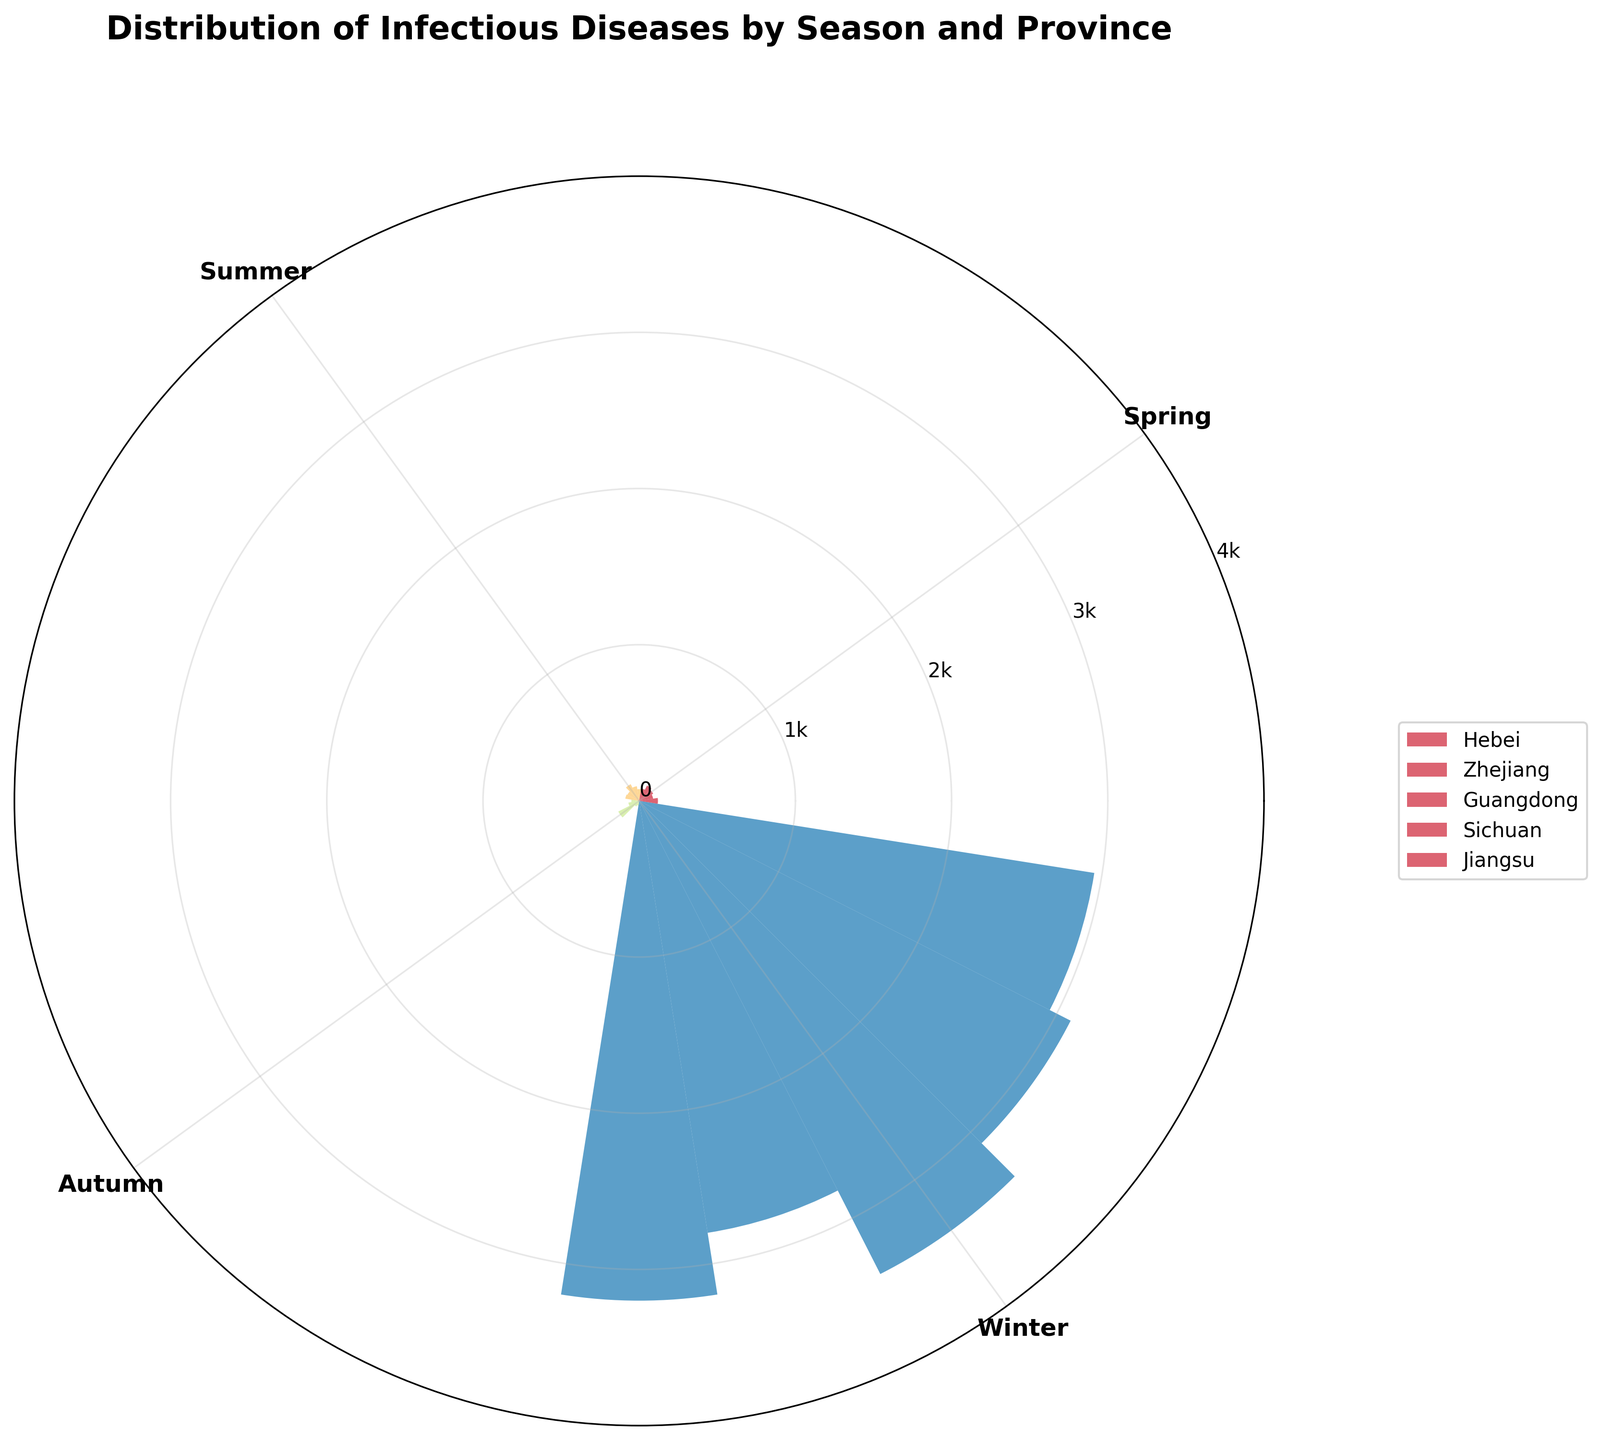How many provinces are included in the data? The legend in the plot lists the provinces included in the data. Each bar represents one province, and there is an entry for each in the legend. The provinces included are Hebei, Zhejiang, Guangdong, Sichuan, and Jiangsu.
Answer: 5 Which season has the highest case count of infectious diseases in Guangdong? The radial bars representing Guangdong show different lengths for each season. The bar corresponding to "Winter" is the longest, indicating the highest case count.
Answer: Winter What is the total case count for Dengue in all provinces during Autumn? Identify the heights of the bars for Dengue in Autumn for each province and sum them up (Hebei: 50, Zhejiang: 70, Guangdong: 150, Sichuan: 40, Jiangsu: 30). The sum is \(50 + 70 + 150 + 40 + 30 = 340\).
Answer: 340 Which province has the lowest case count of Cholera during Summer? Looking at the length of the Cholera bars in Summer for each province, Sichuan has the shortest bar.
Answer: Sichuan Comparing Hebei and Zhejiang, which province has more cases of Measles during Spring? Compare the lengths of the bars for Measles in Spring for both provinces. Hebei has a longer bar than Zhejiang.
Answer: Hebei On average, how many cases of Influenza are there across the provinces during Winter? Find the Influenza case counts for all provinces during Winter (Hebei: 3200, Zhejiang: 2800, Guangdong: 3400, Sichuan: 3100, Jiangsu: 2950), sum them and divide by the number of provinces (5). The sum is \(3200 + 2800 + 3400 + 3100 + 2950 = 15450\), and the average is \(15450 / 5 = 3090\).
Answer: 3090 In which season is the total case count for infectious diseases the highest across all provinces? Sum the radii for each season across all provinces. 
- Spring: Measles (120 + 90 + 100 + 110 + 80 = 500)
- Summer: Cholera (75 + 95 + 120 + 85 + 90 = 465)
- Autumn: Dengue (50 + 70 + 150 + 40 + 30 = 340)
- Winter: Influenza (3200 + 2800 + 3400 + 3100 + 2950 = 15450)
The total for Winter is the highest.
Answer: Winter Which infectious disease has a rising trend in the number of cases from Spring to Winter in Hebei? Look at the radii for each disease in Hebei across the seasons to identify a rising trend. Only Influenza increases significantly, peaking in Winter.
Answer: Influenza Is the number of cases of Cholera in Guangdong greater than that in Zhejiang during Summer? Compare the heights of the Cholera bars for Guangdong and Zhejiang during Summer. Guangdong has a longer bar.
Answer: Yes 